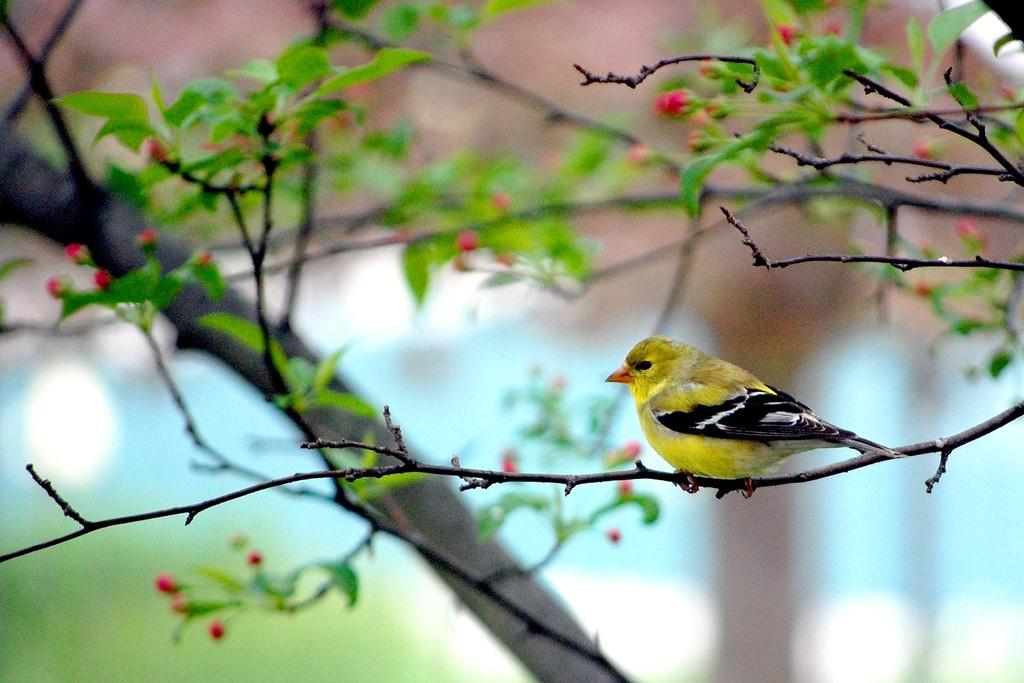What type of animal can be seen in the image? There is a bird in the image. Where is the bird located in the image? The bird is on a branch. What else can be seen on the branch in the image? Branches are visible in the image. What type of vegetation is present in the image? Leaves and flower buds are visible in the image. How would you describe the background of the image? The background of the image is blurry. Can you see any ants crawling on the bird in the image? There are no ants visible in the image. What type of beam is supporting the branch in the image? There is no beam present in the image; the branch is likely part of a tree or plant. 